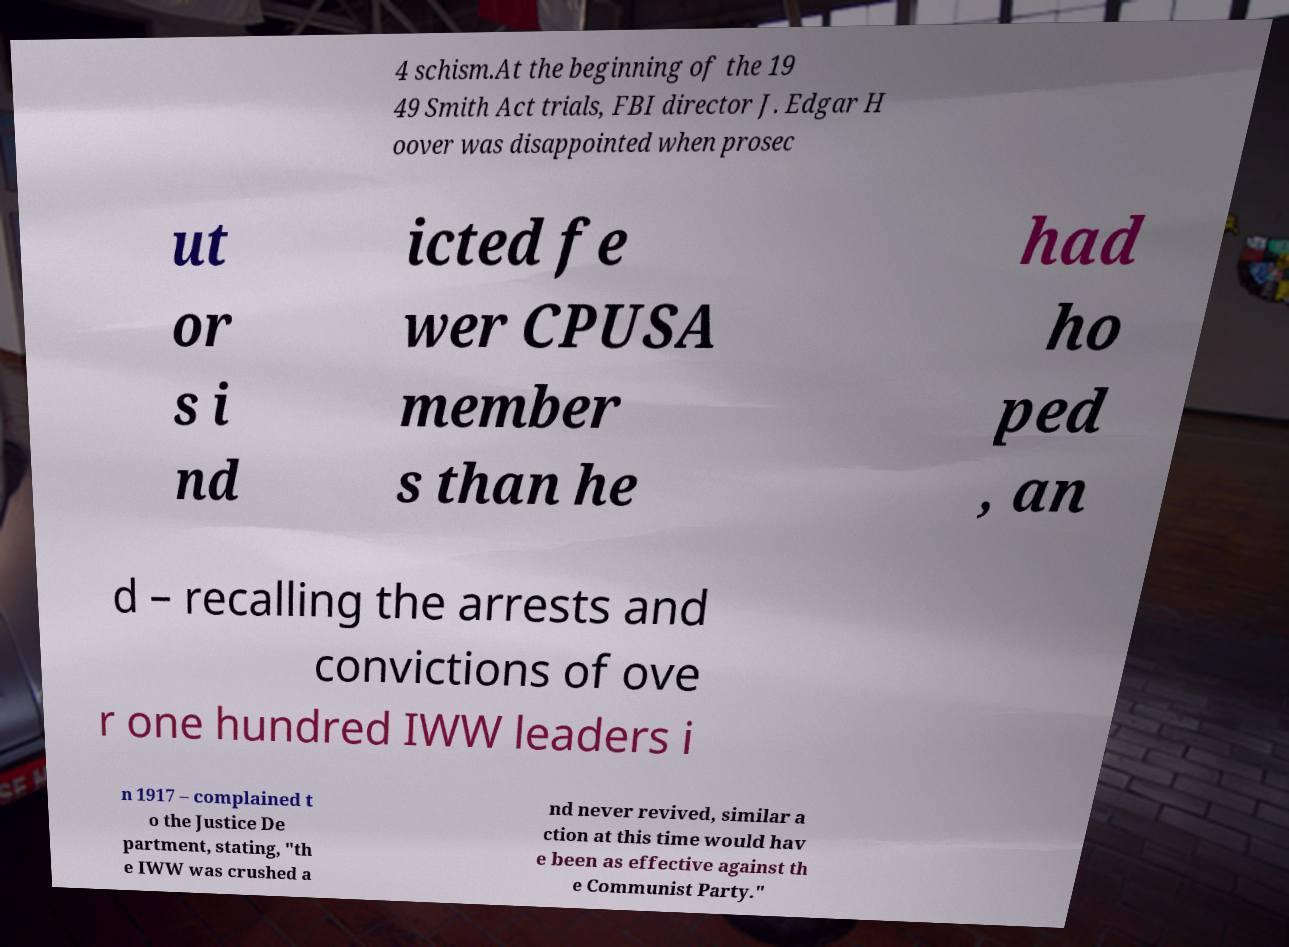There's text embedded in this image that I need extracted. Can you transcribe it verbatim? 4 schism.At the beginning of the 19 49 Smith Act trials, FBI director J. Edgar H oover was disappointed when prosec ut or s i nd icted fe wer CPUSA member s than he had ho ped , an d – recalling the arrests and convictions of ove r one hundred IWW leaders i n 1917 – complained t o the Justice De partment, stating, "th e IWW was crushed a nd never revived, similar a ction at this time would hav e been as effective against th e Communist Party." 